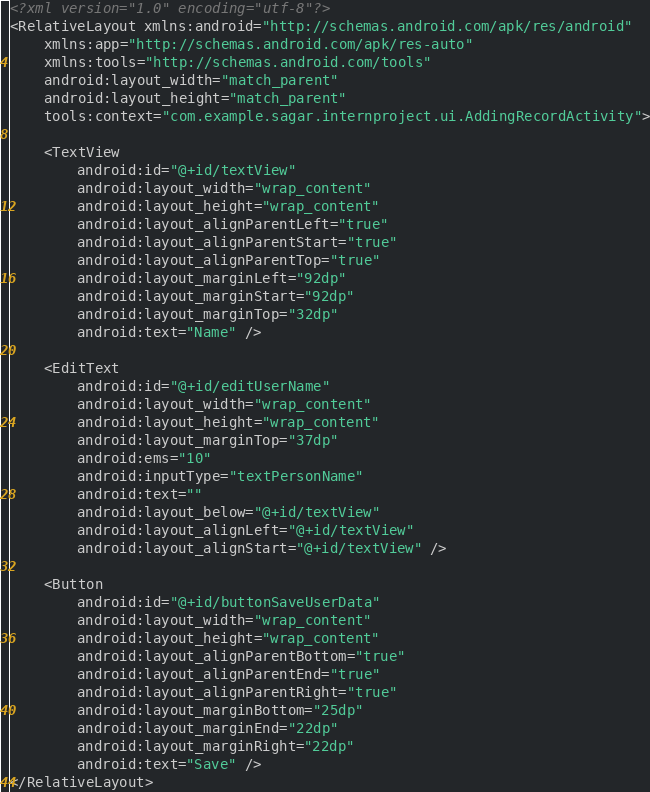<code> <loc_0><loc_0><loc_500><loc_500><_XML_><?xml version="1.0" encoding="utf-8"?>
<RelativeLayout xmlns:android="http://schemas.android.com/apk/res/android"
    xmlns:app="http://schemas.android.com/apk/res-auto"
    xmlns:tools="http://schemas.android.com/tools"
    android:layout_width="match_parent"
    android:layout_height="match_parent"
    tools:context="com.example.sagar.internproject.ui.AddingRecordActivity">

    <TextView
        android:id="@+id/textView"
        android:layout_width="wrap_content"
        android:layout_height="wrap_content"
        android:layout_alignParentLeft="true"
        android:layout_alignParentStart="true"
        android:layout_alignParentTop="true"
        android:layout_marginLeft="92dp"
        android:layout_marginStart="92dp"
        android:layout_marginTop="32dp"
        android:text="Name" />

    <EditText
        android:id="@+id/editUserName"
        android:layout_width="wrap_content"
        android:layout_height="wrap_content"
        android:layout_marginTop="37dp"
        android:ems="10"
        android:inputType="textPersonName"
        android:text=""
        android:layout_below="@+id/textView"
        android:layout_alignLeft="@+id/textView"
        android:layout_alignStart="@+id/textView" />

    <Button
        android:id="@+id/buttonSaveUserData"
        android:layout_width="wrap_content"
        android:layout_height="wrap_content"
        android:layout_alignParentBottom="true"
        android:layout_alignParentEnd="true"
        android:layout_alignParentRight="true"
        android:layout_marginBottom="25dp"
        android:layout_marginEnd="22dp"
        android:layout_marginRight="22dp"
        android:text="Save" />
</RelativeLayout>
</code> 